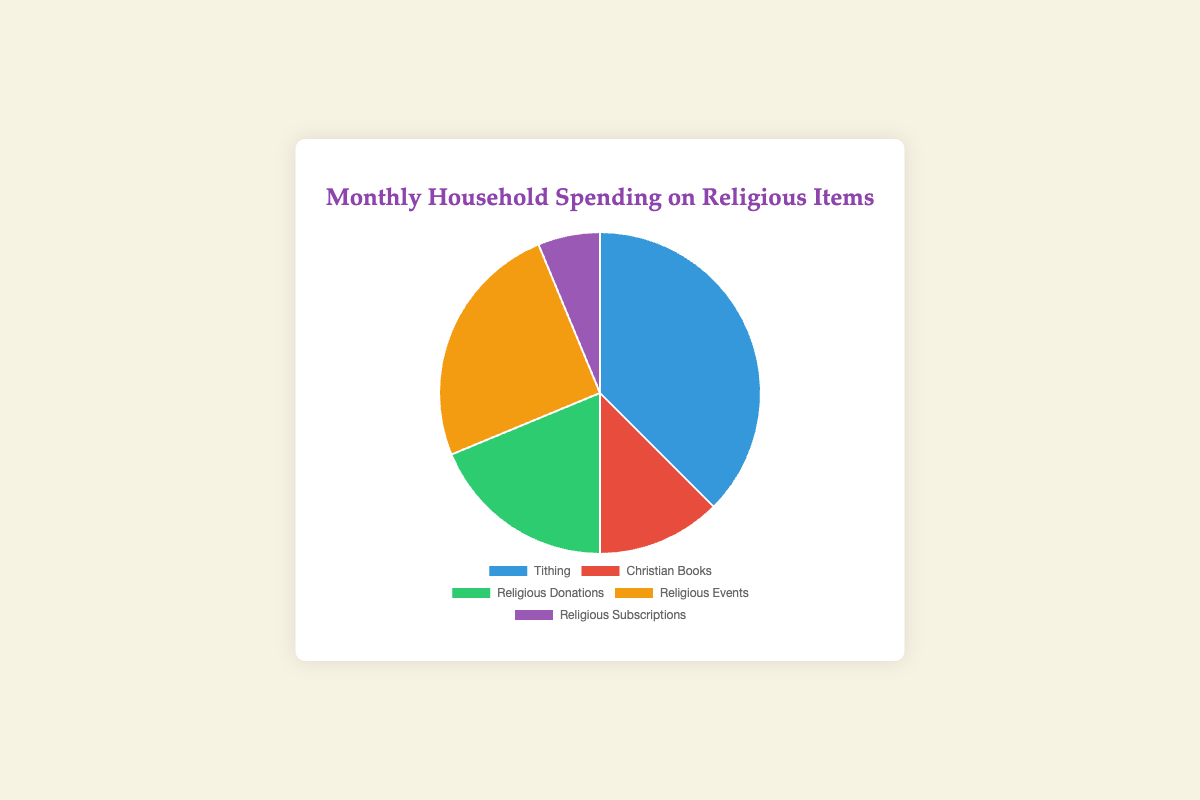What is the total monthly spending on Religious Items? Sum the amounts of all categories: Tithing ($150) + Christian Books ($50) + Religious Donations ($75) + Religious Events ($100) + Religious Subscriptions ($25). The total is $150 + $50 + $75 + $100 + $25 = $400
Answer: $400 Which category has the highest spending, and what is the amount? By examining the data, Tithing has the highest spending at $150.
Answer: Tithing, $150 Which category has the smallest spending, and what is the amount? By examining the data, Religious Subscriptions have the smallest spending at $25.
Answer: Religious Subscriptions, $25 What is the difference in spending between Tithing and Religious Donations? Subtract the amount of Religious Donations ($75) from Tithing ($150): $150 - $75 = $75
Answer: $75 How much more is spent on Christian Books compared to Religious Subscriptions? Subtract the amount of Religious Subscriptions ($25) from Christian Books ($50): $50 - $25 = $25
Answer: $25 What percentage of the total spending is dedicated to Religious Events? The amount spent on Religious Events is $100. The total is $400. To calculate the percentage: ($100 / $400) * 100 = 25%
Answer: 25% Which category is represented by the color red in the pie chart? By examining the pie chart, Christian Books is represented by the color red.
Answer: Christian Books How much do Religious Donations and Religious Events together account for in total spending? Add the amounts of Religious Donations ($75) and Religious Events ($100): $75 + $100 = $175
Answer: $175 What portion of the total spending is outside of Tithing and Religious Donations combined? Calculate the combined spending of Tithing ($150) and Religious Donations ($75): $150 + $75 = $225. Subtract from the total spending of $400: $400 - $225 = $175
Answer: $175 If you were to double the spending on Religious Subscriptions, what will be the new total monthly spending? Double the current spending on Religious Subscriptions: $25 * 2 = $50. Adjust the total by the difference: ($50 - $25) + $400 = $425
Answer: $425 